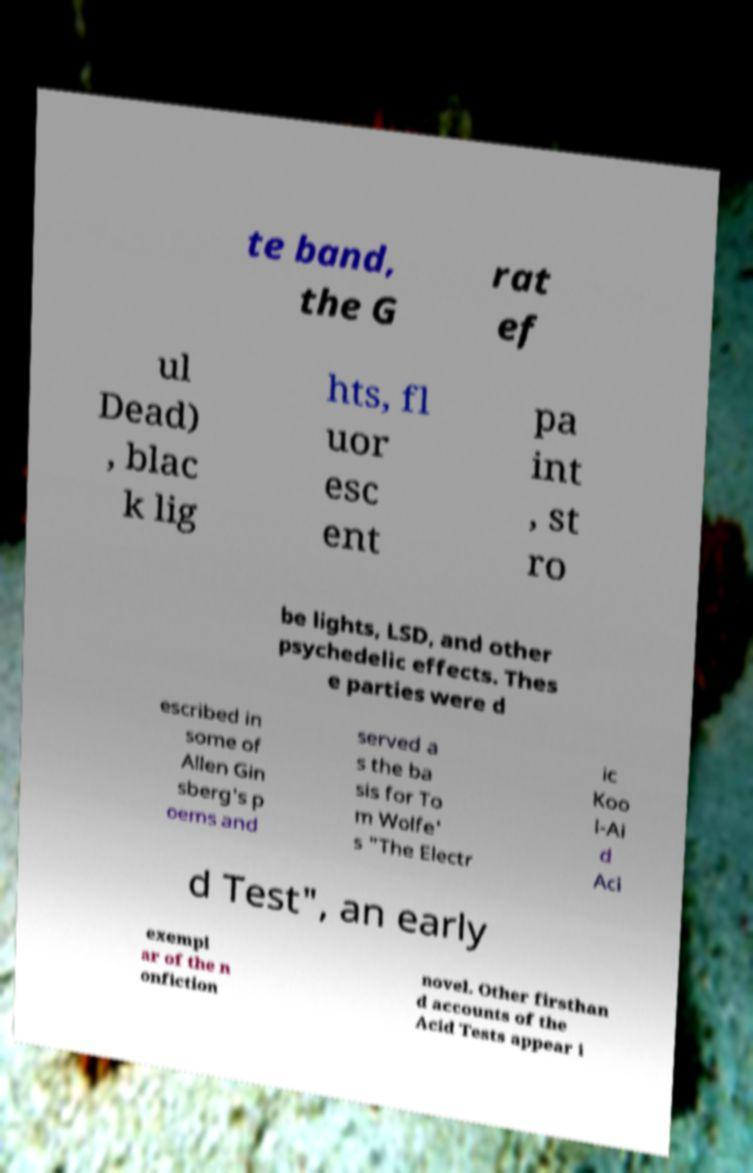Could you extract and type out the text from this image? te band, the G rat ef ul Dead) , blac k lig hts, fl uor esc ent pa int , st ro be lights, LSD, and other psychedelic effects. Thes e parties were d escribed in some of Allen Gin sberg's p oems and served a s the ba sis for To m Wolfe' s "The Electr ic Koo l-Ai d Aci d Test", an early exempl ar of the n onfiction novel. Other firsthan d accounts of the Acid Tests appear i 